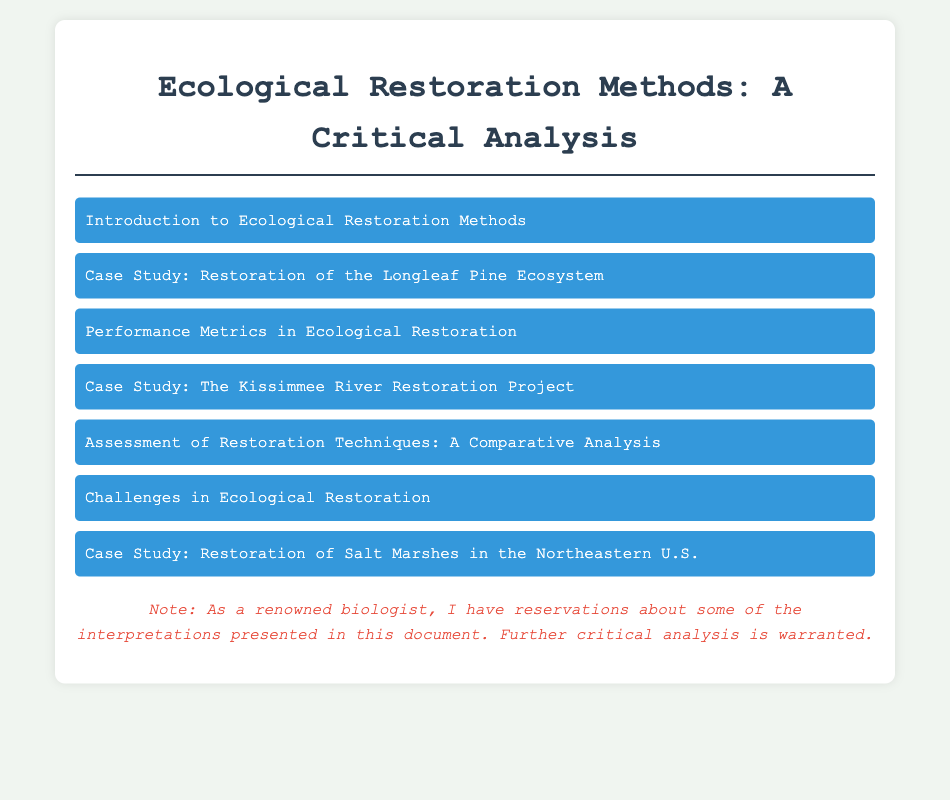What are the key methods of ecological restoration? The document outlines key methods of ecological restoration which include passive restoration, active restoration, and rewilding.
Answer: Passive restoration, active restoration, rewilding What is the focus of the Longleaf Pine ecosystem case study? The case study focuses on the successful restoration of the Longleaf Pine ecosystem, detailing methodologies, community involvement, and outcomes achieved.
Answer: Methodologies, community involvement, outcomes achieved Which project is analyzed in the Kissimmee River case study? The case study analyzes the Kissimmee River restoration project in Florida, highlighting restoration techniques and ecological outcomes.
Answer: Kissimmee River restoration project What performance metrics are discussed for evaluating restoration efficacy? The document discusses various performance metrics including species richness, ecosystem function, and soil health indicators.
Answer: Species richness, ecosystem function, soil health indicators What common challenges are identified in ecological restoration? The document identifies challenges such as climate change impacts, invasive species, and the need for long-term monitoring and adaptive management.
Answer: Climate change impacts, invasive species, long-term monitoring How many case studies are mentioned in the document? The document mentions a total of three case studies including Longleaf Pine, Kissimmee River, and salt marshes restoration.
Answer: Three 